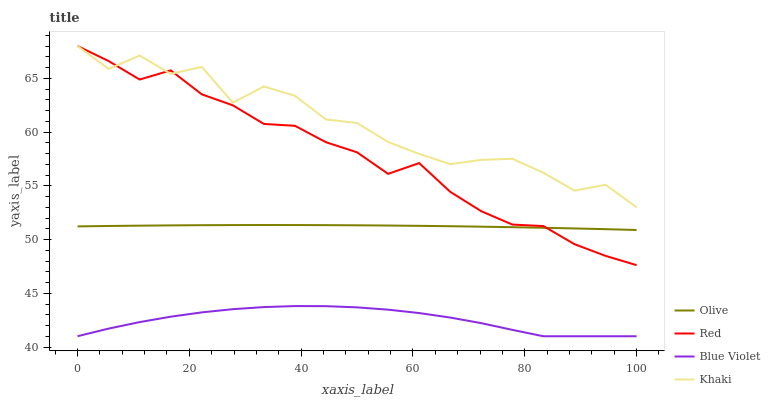Does Blue Violet have the minimum area under the curve?
Answer yes or no. Yes. Does Khaki have the maximum area under the curve?
Answer yes or no. Yes. Does Khaki have the minimum area under the curve?
Answer yes or no. No. Does Blue Violet have the maximum area under the curve?
Answer yes or no. No. Is Olive the smoothest?
Answer yes or no. Yes. Is Khaki the roughest?
Answer yes or no. Yes. Is Blue Violet the smoothest?
Answer yes or no. No. Is Blue Violet the roughest?
Answer yes or no. No. Does Blue Violet have the lowest value?
Answer yes or no. Yes. Does Khaki have the lowest value?
Answer yes or no. No. Does Red have the highest value?
Answer yes or no. Yes. Does Blue Violet have the highest value?
Answer yes or no. No. Is Blue Violet less than Red?
Answer yes or no. Yes. Is Khaki greater than Blue Violet?
Answer yes or no. Yes. Does Khaki intersect Red?
Answer yes or no. Yes. Is Khaki less than Red?
Answer yes or no. No. Is Khaki greater than Red?
Answer yes or no. No. Does Blue Violet intersect Red?
Answer yes or no. No. 